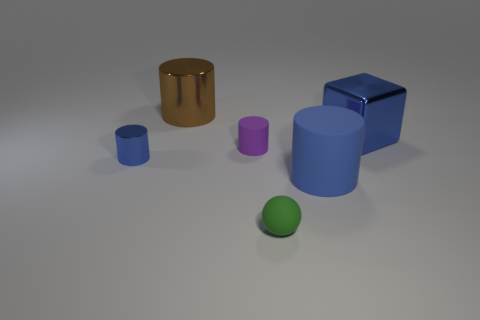Do the green thing and the small purple cylinder have the same material?
Make the answer very short. Yes. What number of objects are either small things that are left of the large brown cylinder or tiny purple metal cylinders?
Provide a short and direct response. 1. There is a cube that is the same size as the blue matte thing; what is its material?
Your response must be concise. Metal. What is the material of the big cylinder that is behind the tiny thing that is left of the thing that is behind the cube?
Offer a very short reply. Metal. What color is the ball?
Provide a succinct answer. Green. What number of large objects are either green rubber balls or purple cylinders?
Offer a very short reply. 0. There is a small cylinder that is the same color as the big metallic block; what is it made of?
Make the answer very short. Metal. Do the small thing in front of the blue metallic cylinder and the blue cylinder that is on the right side of the tiny green object have the same material?
Make the answer very short. Yes. Are any big gray matte objects visible?
Your answer should be very brief. No. Is the number of shiny cubes on the left side of the large metallic cube greater than the number of tiny blue cylinders that are behind the big brown cylinder?
Make the answer very short. No. 